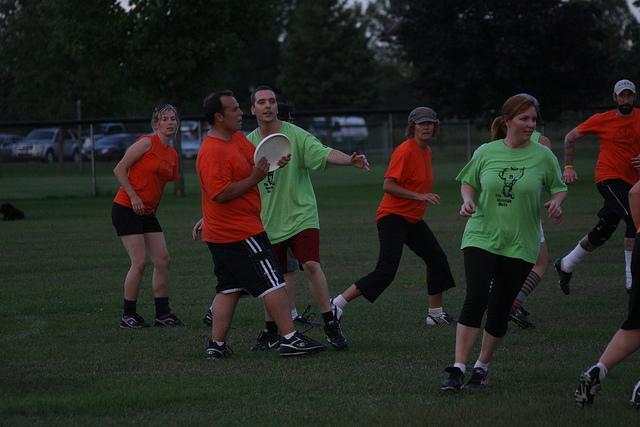How many are wearing orange shirts?
Give a very brief answer. 4. How many players are pictured?
Give a very brief answer. 8. How many of these people are women?
Give a very brief answer. 3. How many people are wearing hoodies?
Give a very brief answer. 0. How many people can be seen?
Give a very brief answer. 7. 